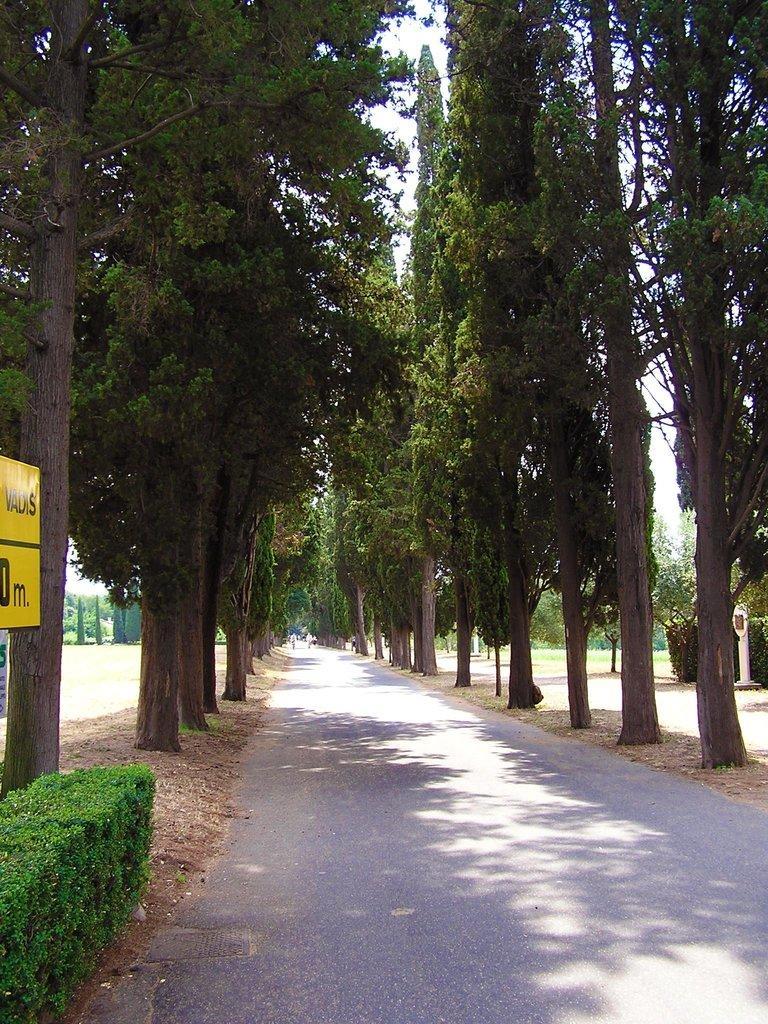Could you give a brief overview of what you see in this image? In this image we can see the road and there are some trees and plants and we can see a yellow board with some text on the left side of the image. 